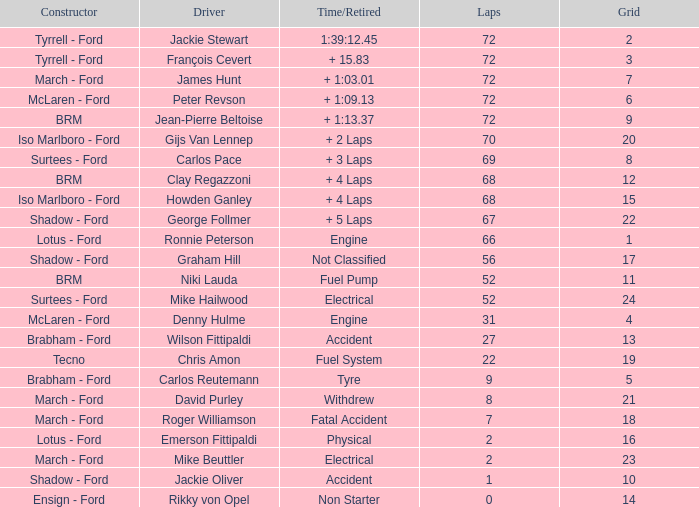What is the top grid that laps less than 66 and a retried engine? 4.0. 